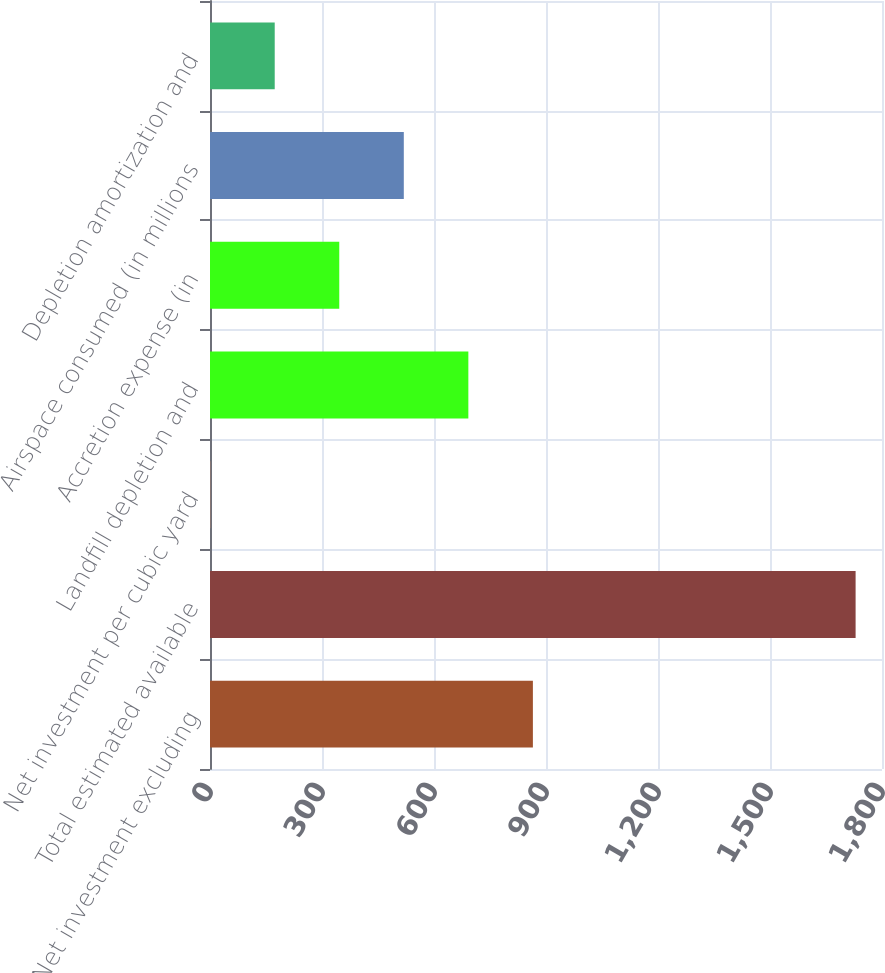<chart> <loc_0><loc_0><loc_500><loc_500><bar_chart><fcel>Net investment excluding<fcel>Total estimated available<fcel>Net investment per cubic yard<fcel>Landfill depletion and<fcel>Accretion expense (in<fcel>Airspace consumed (in millions<fcel>Depletion amortization and<nl><fcel>864.88<fcel>1729.3<fcel>0.48<fcel>692<fcel>346.24<fcel>519.12<fcel>173.36<nl></chart> 